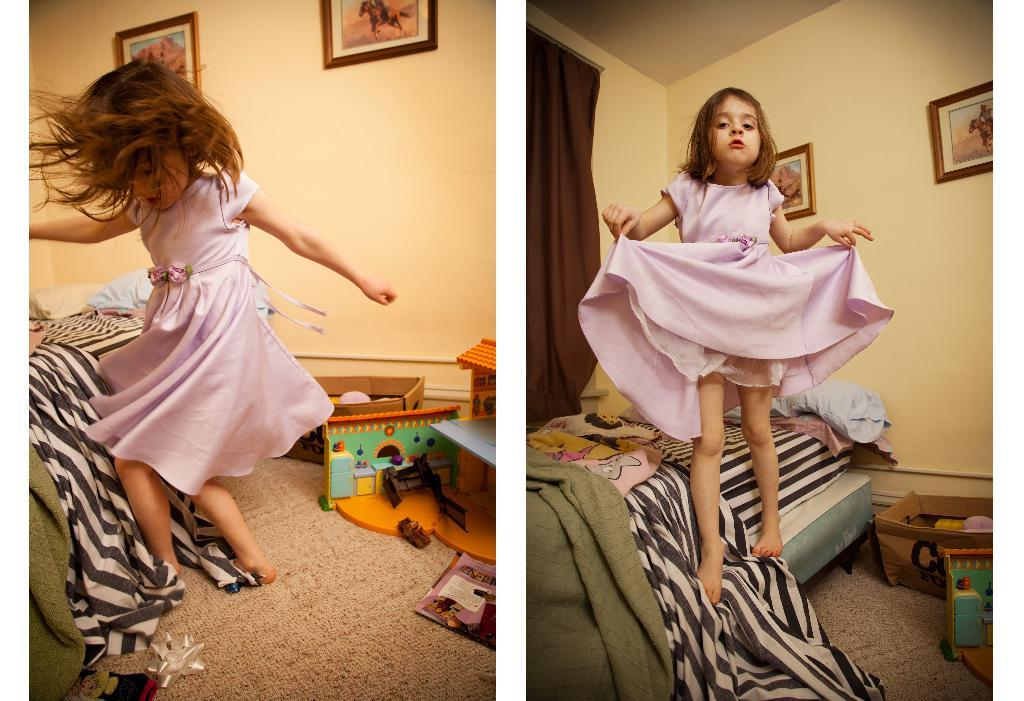Who is the main subject in the image? There is a girl in the image. What is the girl doing in the image? The girl is playing in the image. Where is the girl standing in the image? The girl is standing on a bed in the image. What can be seen on the floor in the image? There are toys on the carpet in the image. What is visible on the wall in the image? There are photos on the wall in the image. How does the girl adjust the flock of birds in the image? There are no birds present in the image, so the girl cannot adjust a flock of birds. 